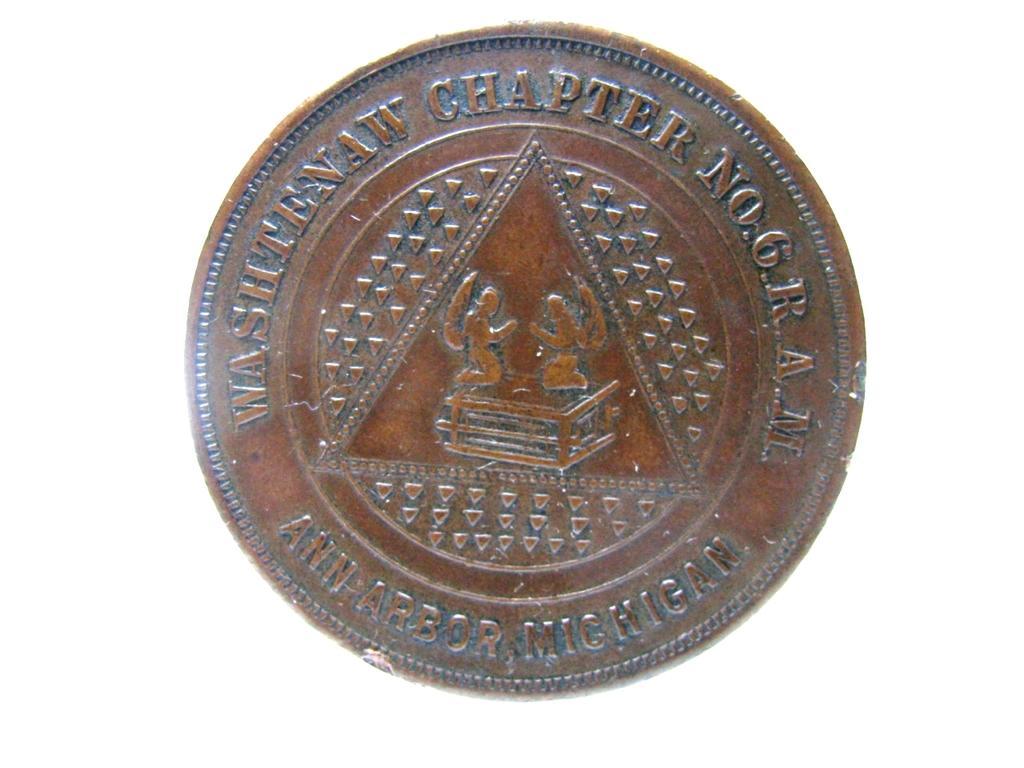How would you summarize this image in a sentence or two? This is the picture of a coin. There is a text on the coin. 